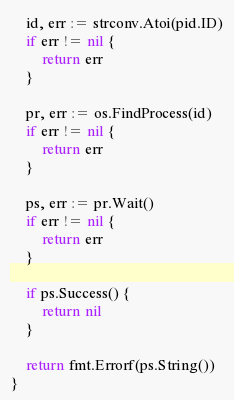Convert code to text. <code><loc_0><loc_0><loc_500><loc_500><_Go_>	id, err := strconv.Atoi(pid.ID)
	if err != nil {
		return err
	}

	pr, err := os.FindProcess(id)
	if err != nil {
		return err
	}

	ps, err := pr.Wait()
	if err != nil {
		return err
	}

	if ps.Success() {
		return nil
	}

	return fmt.Errorf(ps.String())
}
</code> 